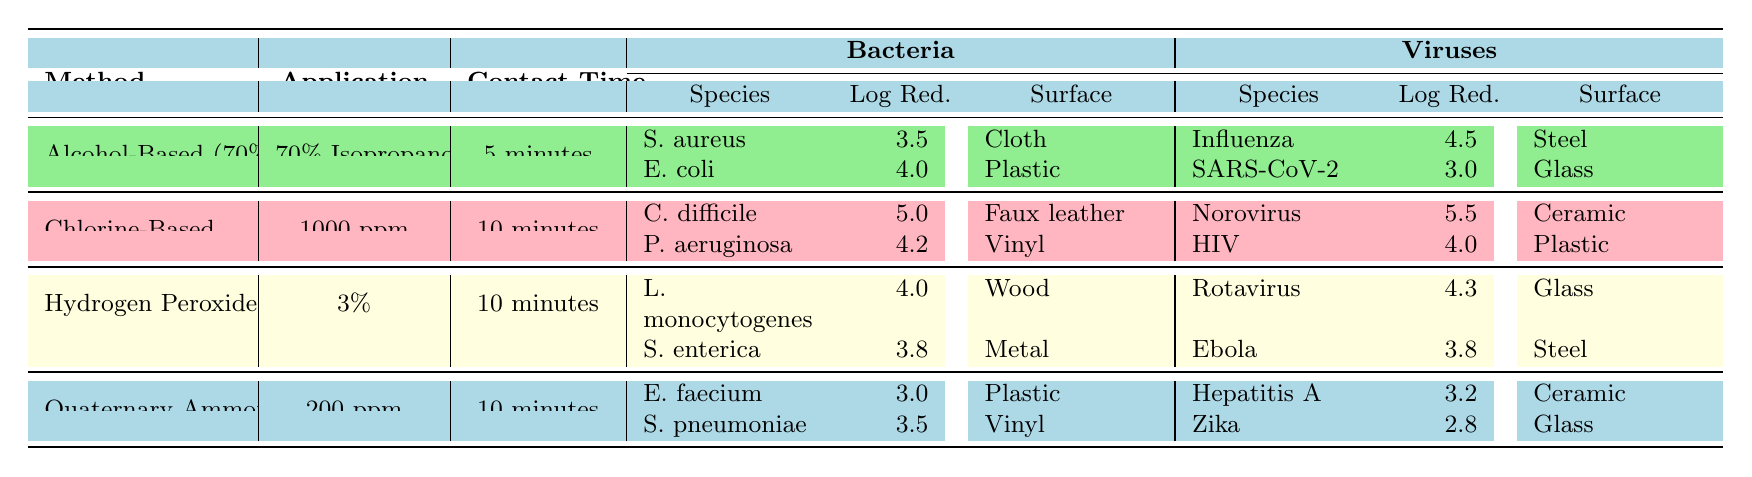What is the log reduction of Staphylococcus aureus when using Alcohol-Based Disinfectants? The table shows that the log reduction for Staphylococcus aureus with Alcohol-Based Disinfectants is 3.5.
Answer: 3.5 Which disinfection method is the most effective against Clostridium difficile? The log reduction for Clostridium difficile when using Chlorine-Based Disinfectants is 5.0, which is the highest value in the table for this bacteria.
Answer: Chlorine-Based Disinfectants What is the contact time for Hydrogen Peroxide disinfection? The table indicates that the contact time for Hydrogen Peroxide is 10 minutes.
Answer: 10 minutes How many viruses are listed under Quaternary Ammonium Compounds? Under Quaternary Ammonium Compounds, there are two viruses listed: Hepatitis A and Zika Virus.
Answer: Two Which method shows a higher log reduction for bacteria: Alcohol-Based or Chlorine-Based disinfectants? Alcohol-Based disinfectants show a maximum log reduction of 4.0 (for E. coli), while Chlorine-Based disinfectants have a maximum of 5.0 (for C. difficile). Thus, Chlorine-Based disinfectants are more effective.
Answer: Chlorine-Based disinfectants What is the average log reduction for viruses when using Hydrogen Peroxide? The table lists two viruses for Hydrogen Peroxide: Rotavirus with a log reduction of 4.3 and Ebola Virus with a log reduction of 3.8. The average is (4.3 + 3.8) / 2 = 4.05.
Answer: 4.05 Is the log reduction against HIV higher than that against SARS-CoV-2? The log reduction for HIV is 4.0, whereas for SARS-CoV-2 it is 3.0. Since 4.0 is greater than 3.0, the statement is true.
Answer: Yes Which disinfectant has consistently higher log reductions for both bacteria and viruses compared to the others? Chlorine-Based Disinfectants have the highest log reductions for both Clostridium difficile (5.0) and Norovirus (5.5), indicating they are the most effective disinfectants overall in this table.
Answer: Chlorine-Based Disinfectants What is the difference in log reduction for Listeria monocytogenes and Salmonella enterica when using Hydrogen Peroxide? The log reduction for Listeria monocytogenes is 4.0 and for Salmonella enterica is 3.8. The difference is 4.0 - 3.8 = 0.2.
Answer: 0.2 How many surfaces were tested for Quaternary Ammonium Compounds? The table shows that two surfaces were tested: Plastic and Vinyl.
Answer: Two surfaces What is the total log reduction achieved for all bacteria using Chlorine-Based Disinfectants? The log reductions for the bacteria Clostridium difficile (5.0) and Pseudomonas aeruginosa (4.2) lead to a total of 5.0 + 4.2 = 9.2.
Answer: 9.2 